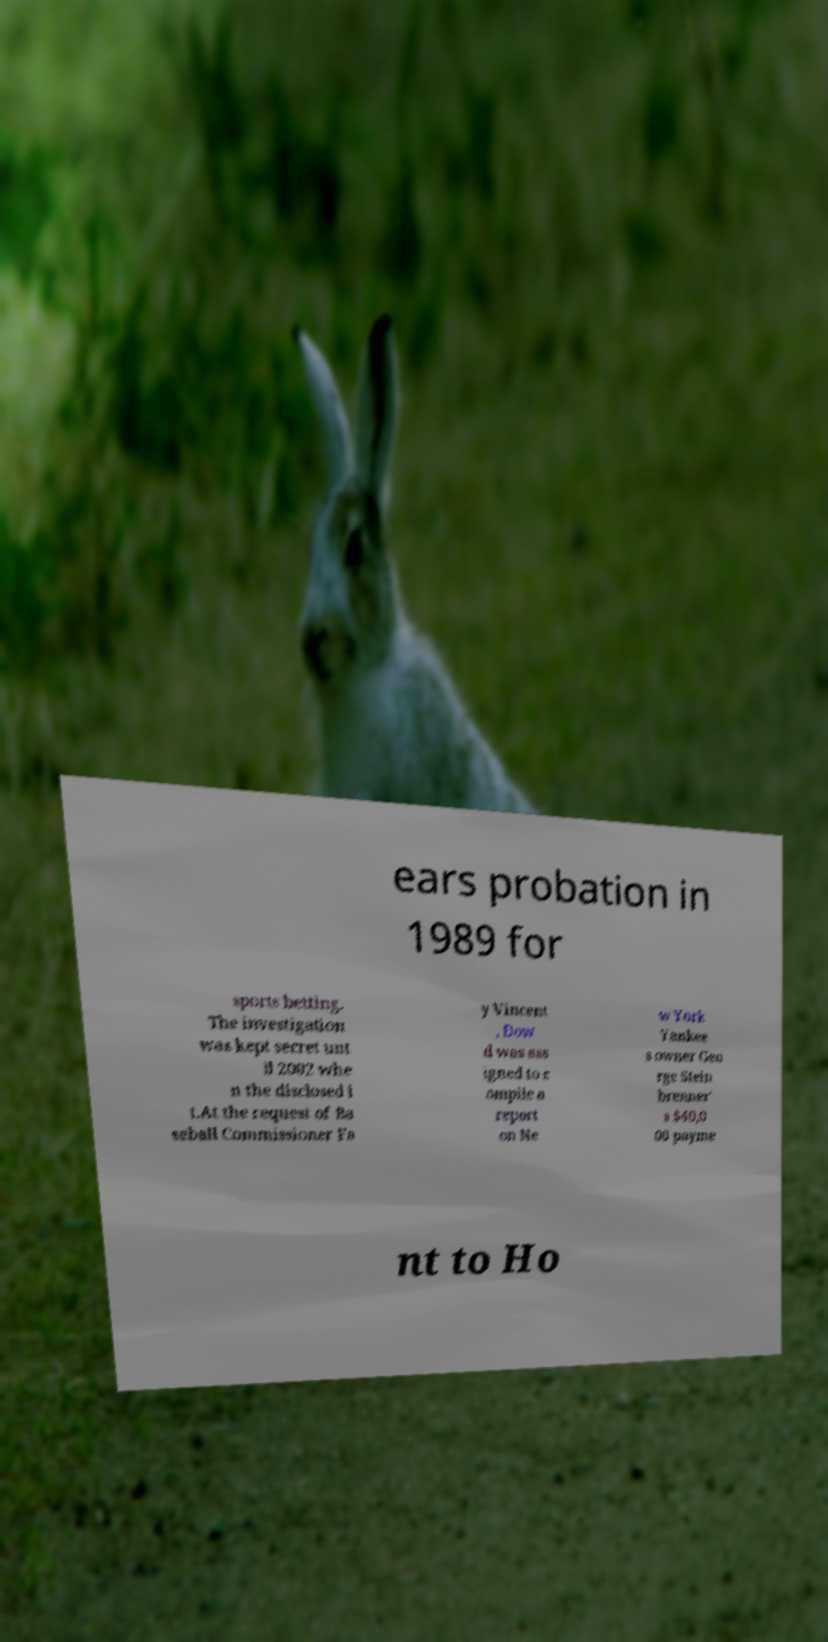Can you accurately transcribe the text from the provided image for me? ears probation in 1989 for sports betting. The investigation was kept secret unt il 2002 whe n the disclosed i t.At the request of Ba seball Commissioner Fa y Vincent , Dow d was ass igned to c ompile a report on Ne w York Yankee s owner Geo rge Stein brenner' s $40,0 00 payme nt to Ho 